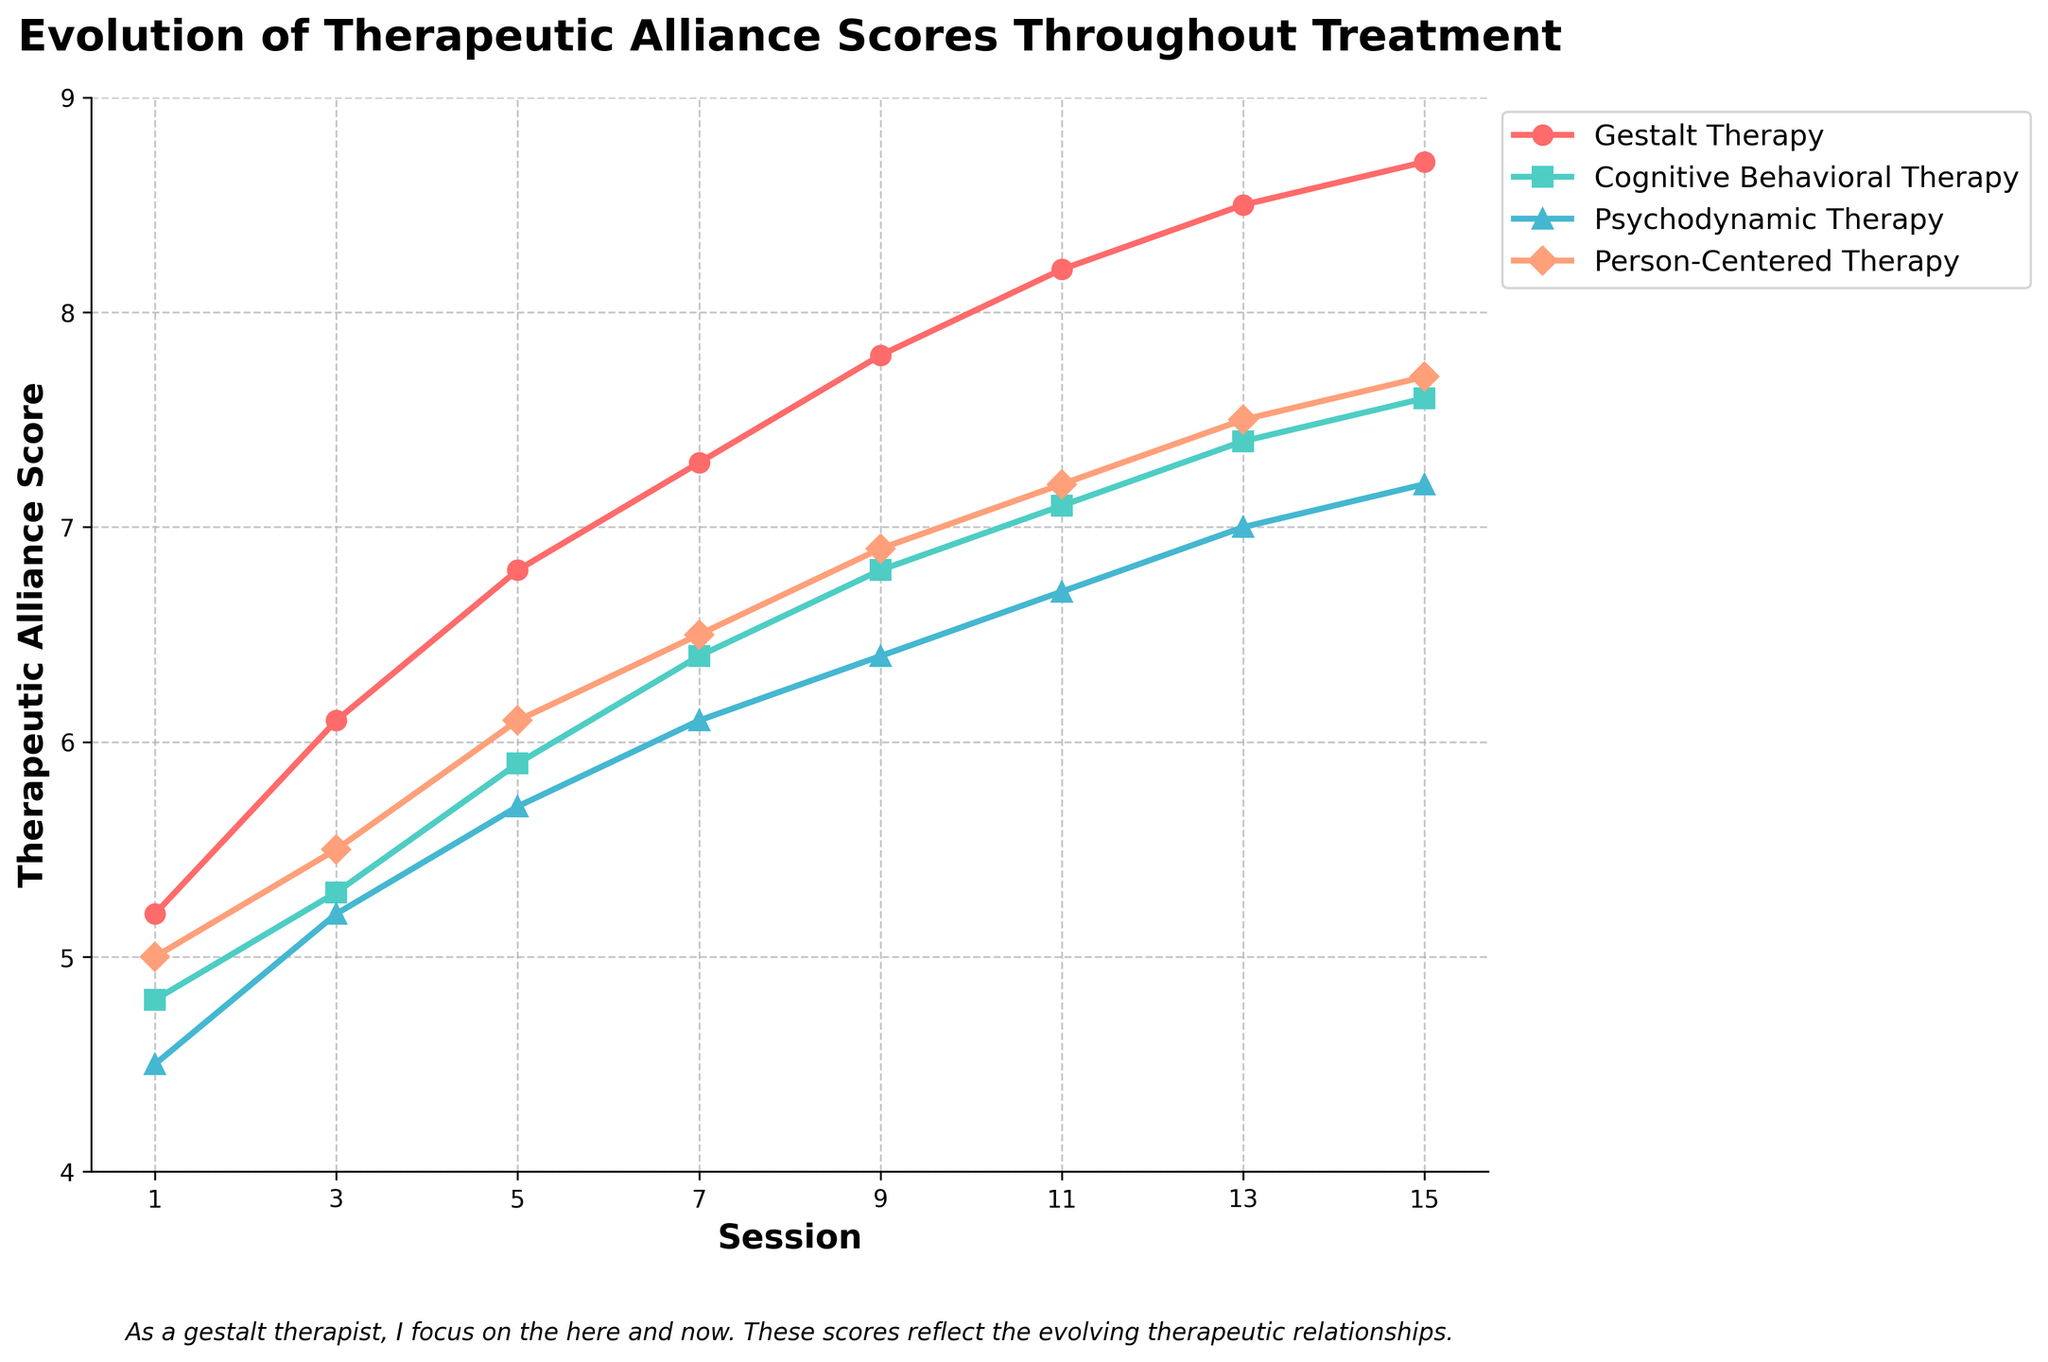What is the title of the figure? The title is located at the top of the figure and provides a summary of what the chart represents.
Answer: Evolution of Therapeutic Alliance Scores Throughout Treatment How many sessions are shown in the figure? The x-axis of the figure represents the session number, and from the x-axis ticks, we can count the number of sessions.
Answer: 8 Which therapeutic modality shows the highest therapeutic alliance score at session 11? At session 11, find the highest value among the lines that represent different therapies, noted by their respective markers and colors.
Answer: Gestalt Therapy What is the difference in the therapeutic alliance score for Gestalt Therapy between session 1 and session 15? Subtract the therapeutic alliance score of session 1 from the score of session 15 in the Gestalt Therapy line plot. The scores are 8.7 (session 15) and 5.2 (session 1). 8.7 - 5.2 = 3.5.
Answer: 3.5 Which two therapies have the closest therapeutic alliance scores at session 9? At session 9, compare the scores for all four therapies and identify the two that have the smallest difference. Gestalt Therapy (7.8), Cognitive Behavioral Therapy (6.8), Psychodynamic Therapy (6.4), Person-Centered Therapy (6.9). The closest scores are for Cognitive Behavioral Therapy and Person-Centered Therapy. 6.9 - 6.8 = 0.1.
Answer: Cognitive Behavioral Therapy and Person-Centered Therapy What is the average therapeutic alliance score for Cognitive Behavioral Therapy for all sessions shown? Add all the therapeutic alliance scores for Cognitive Behavioral Therapy and divide by the number of sessions. (4.8 + 5.3 + 5.9 + 6.4 + 6.8 + 7.1 + 7.4 + 7.6) / 8. Sum is 51.3. 51.3 / 8 = 6.41 (rounded to two decimal places).
Answer: 6.41 Which therapeutic modality shows the most consistent improvement in scores across sessions? Look at the slope of the lines for each therapy. The line with the most consistent upward trend and least fluctuation in gradient indicates the most consistent improvement.
Answer: Gestalt Therapy How does the therapeutic alliance score for Psychodynamic Therapy at session 7 compare to Person-Centered Therapy at session 7? Check the scores at session 7 for both therapies: Psychodynamic Therapy is 6.1, and Person-Centered Therapy is 6.5. Compare the two values directly.
Answer: Psychodynamic Therapy is lower What is the total increase in the therapeutic alliance scores from session 1 to session 15 for all therapies combined? Calculate the difference between the scores at session 15 and session 1 for each therapy and sum them up. Gestalt Therapy: 8.7 - 5.2 = 3.5, Cognitive Behavioral Therapy: 7.6 - 4.8 = 2.8, Psychodynamic Therapy: 7.2 - 4.5 = 2.7, Person-Centered Therapy: 7.7 - 5.0 = 2.7. Total increase: 3.5 + 2.8 + 2.7 + 2.7 = 11.7.
Answer: 11.7 